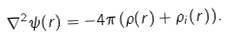Convert formula to latex. <formula><loc_0><loc_0><loc_500><loc_500>\nabla ^ { 2 } \psi ( r ) = - 4 \pi \, ( \rho ( r ) + \rho _ { i } ( r ) ) .</formula> 